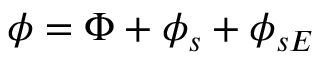Convert formula to latex. <formula><loc_0><loc_0><loc_500><loc_500>\phi = \Phi + \phi _ { s } + \phi _ { s E }</formula> 